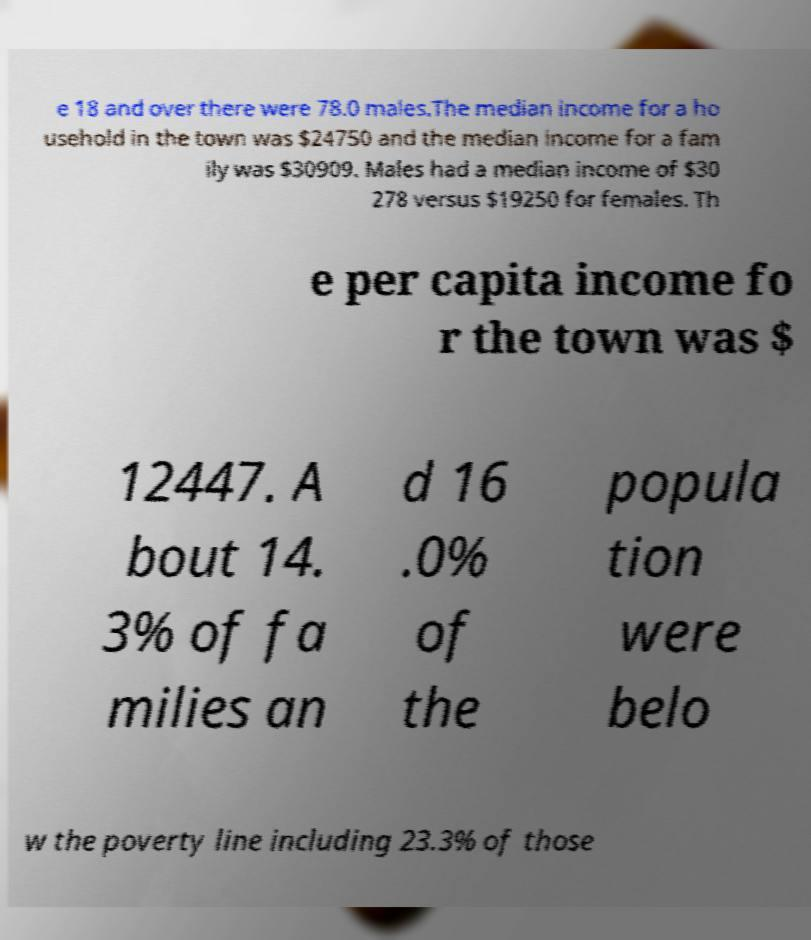What messages or text are displayed in this image? I need them in a readable, typed format. e 18 and over there were 78.0 males.The median income for a ho usehold in the town was $24750 and the median income for a fam ily was $30909. Males had a median income of $30 278 versus $19250 for females. Th e per capita income fo r the town was $ 12447. A bout 14. 3% of fa milies an d 16 .0% of the popula tion were belo w the poverty line including 23.3% of those 